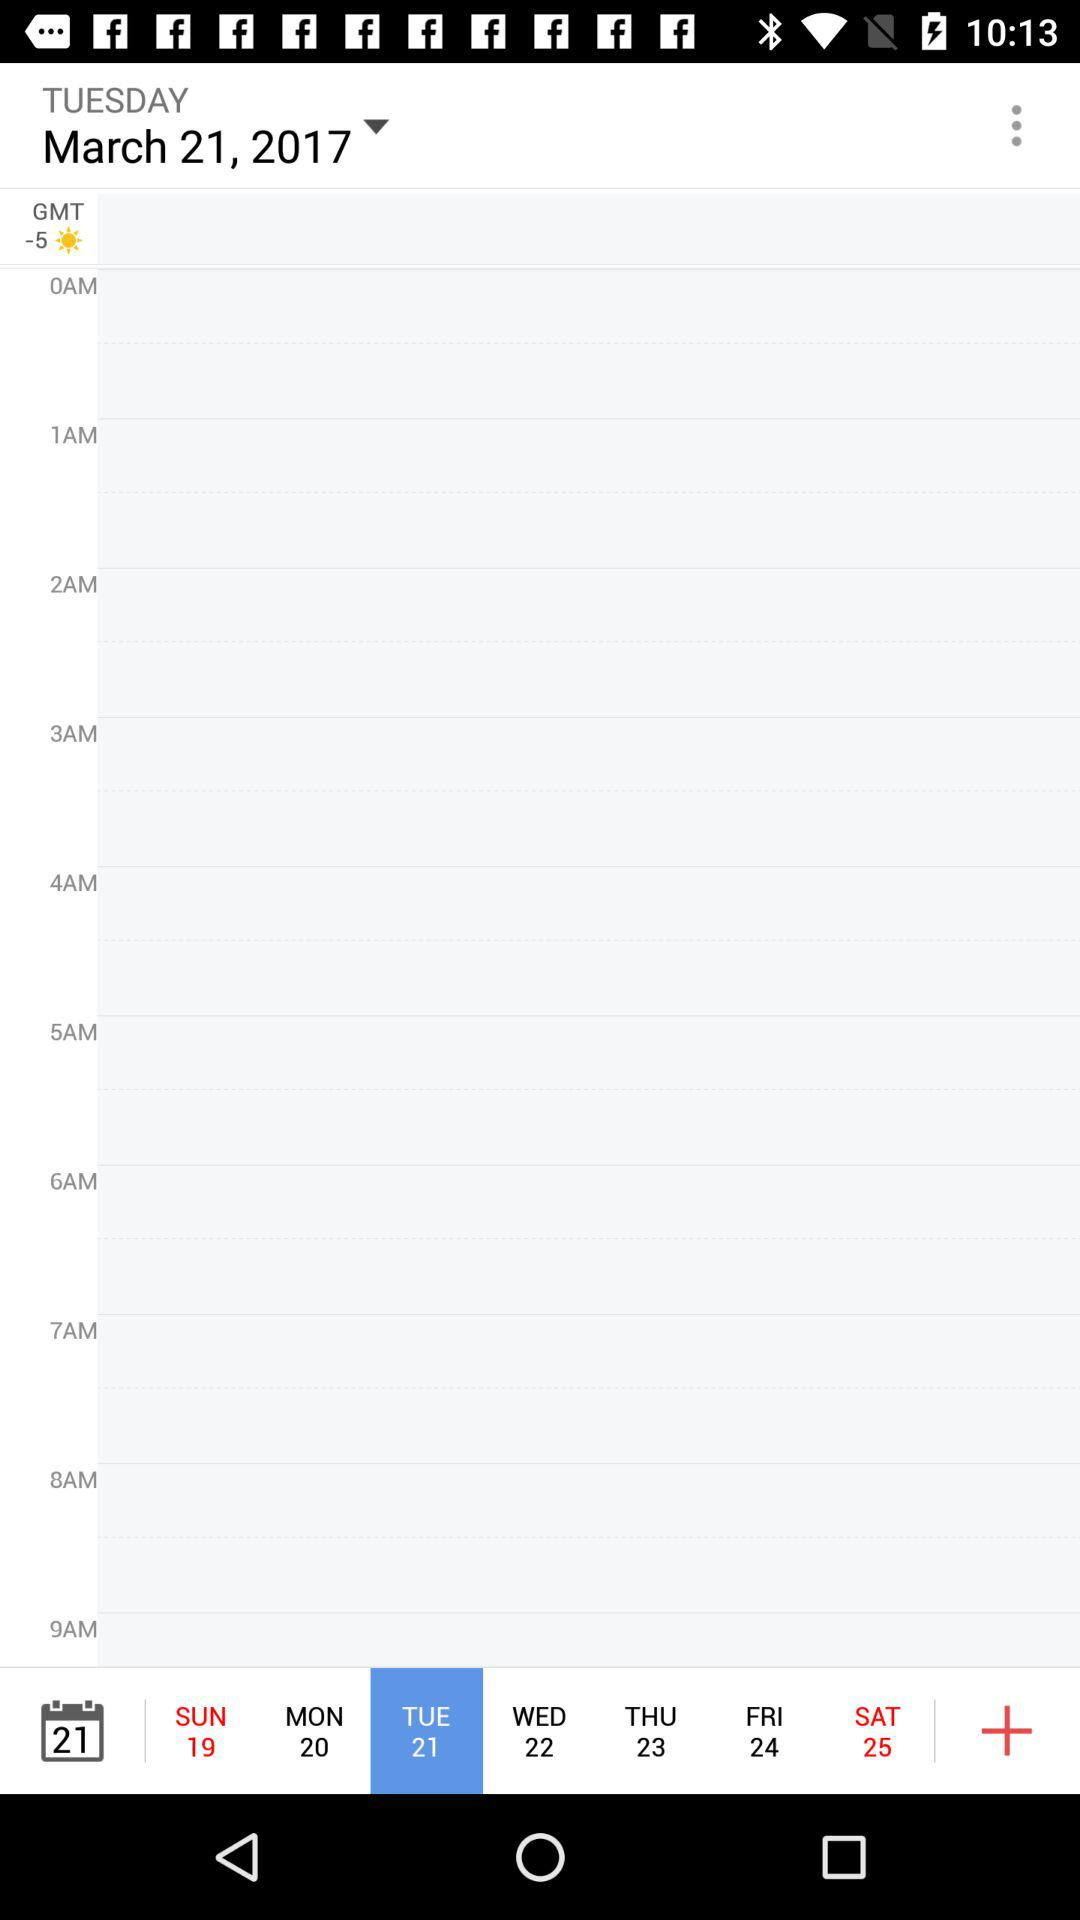What is the selected date? The selected date is Tuesday, March 21, 2017. 